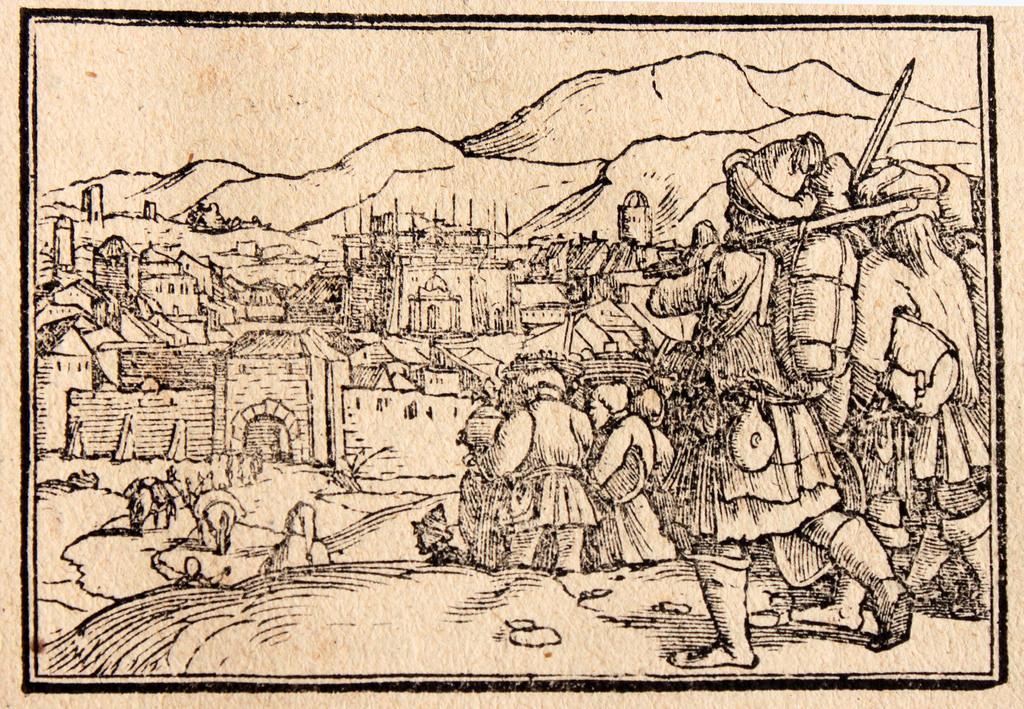In one or two sentences, can you explain what this image depicts? This image is a drawing. In this image we can see persons, camels, buildings, hills and sky. 